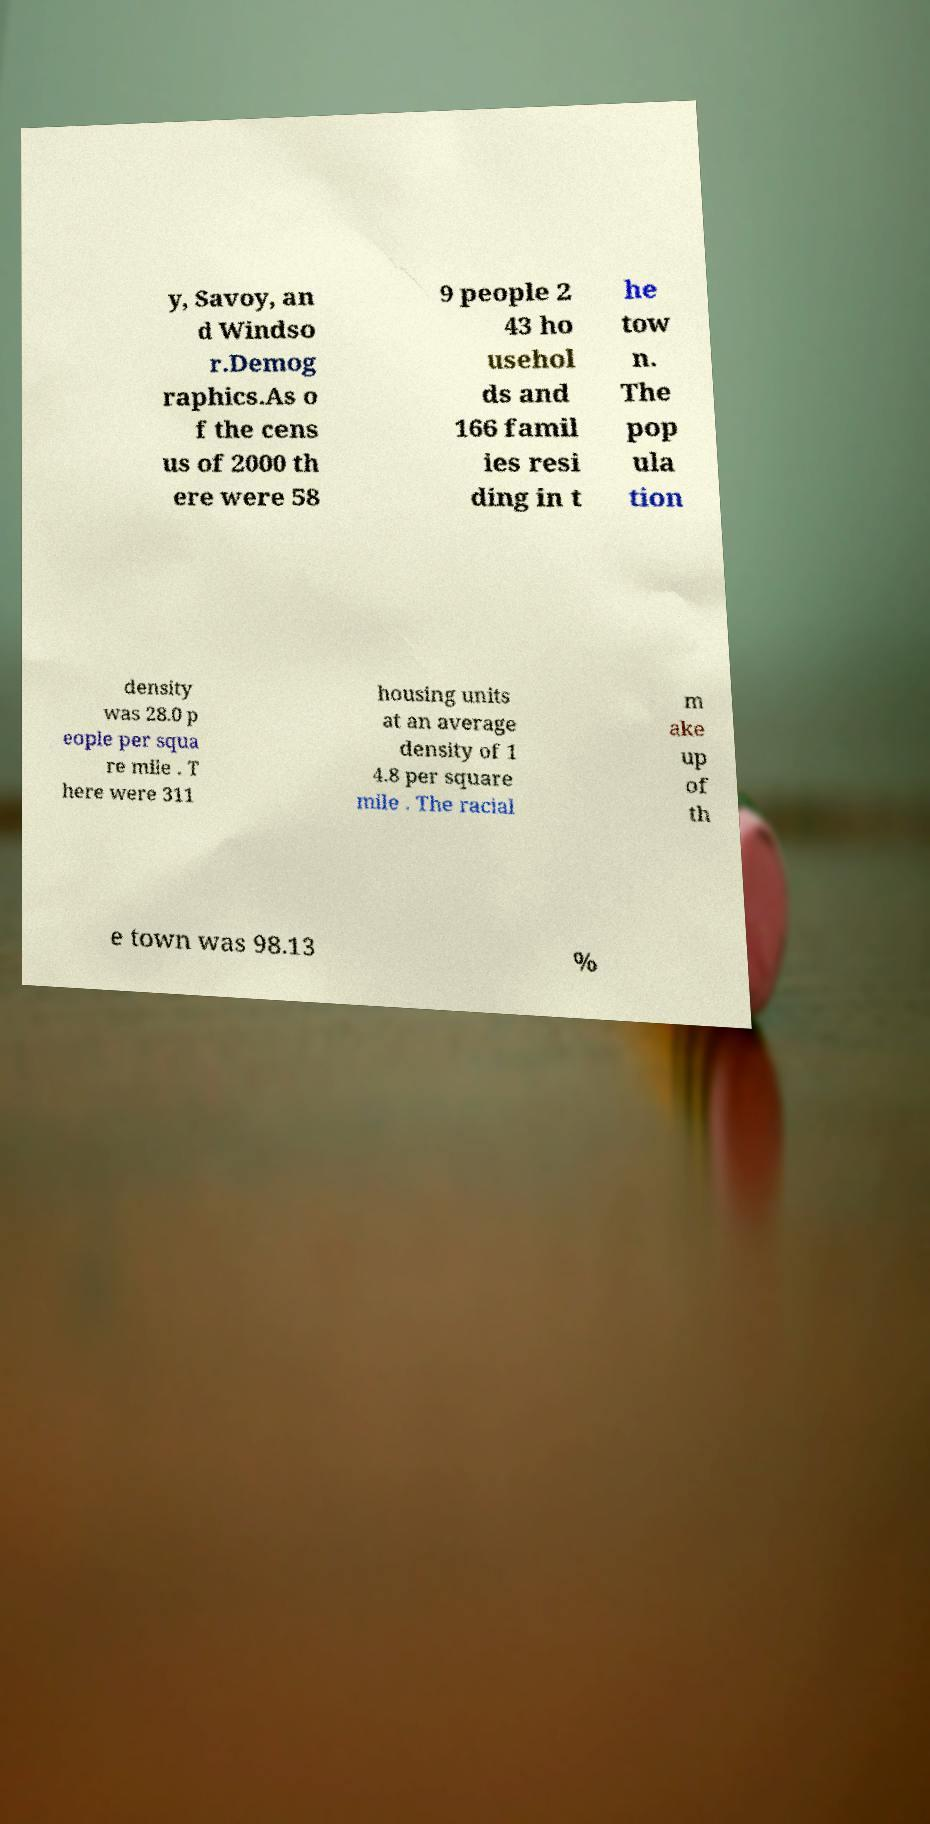Could you assist in decoding the text presented in this image and type it out clearly? y, Savoy, an d Windso r.Demog raphics.As o f the cens us of 2000 th ere were 58 9 people 2 43 ho usehol ds and 166 famil ies resi ding in t he tow n. The pop ula tion density was 28.0 p eople per squa re mile . T here were 311 housing units at an average density of 1 4.8 per square mile . The racial m ake up of th e town was 98.13 % 